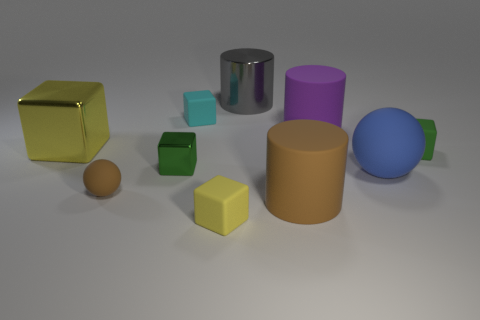Subtract all yellow matte cubes. How many cubes are left? 4 Subtract all cylinders. How many objects are left? 7 Subtract 2 cylinders. How many cylinders are left? 1 Subtract all brown spheres. How many spheres are left? 1 Add 8 large cubes. How many large cubes exist? 9 Subtract 1 green cubes. How many objects are left? 9 Subtract all red balls. Subtract all gray cubes. How many balls are left? 2 Subtract all blue cylinders. How many brown spheres are left? 1 Subtract all big metallic objects. Subtract all large blue balls. How many objects are left? 7 Add 7 small cyan things. How many small cyan things are left? 8 